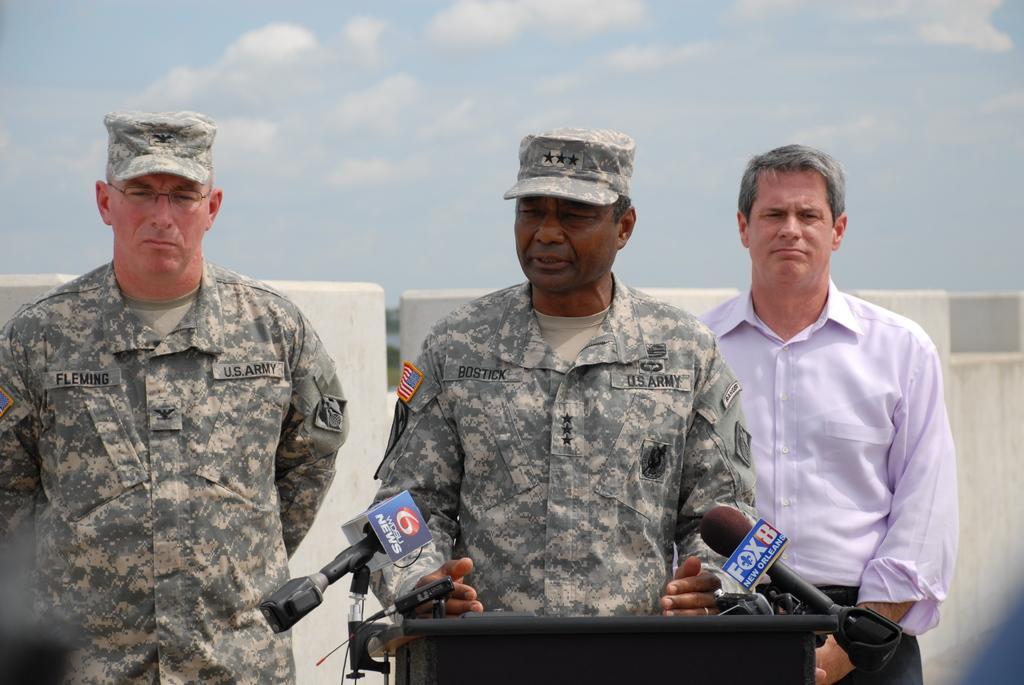Can you describe this image briefly? In the image there is a man speaking something, in front of the man there is a table and there are two mics attached to that table, there are two other people around the man, behind them there is a wall. 